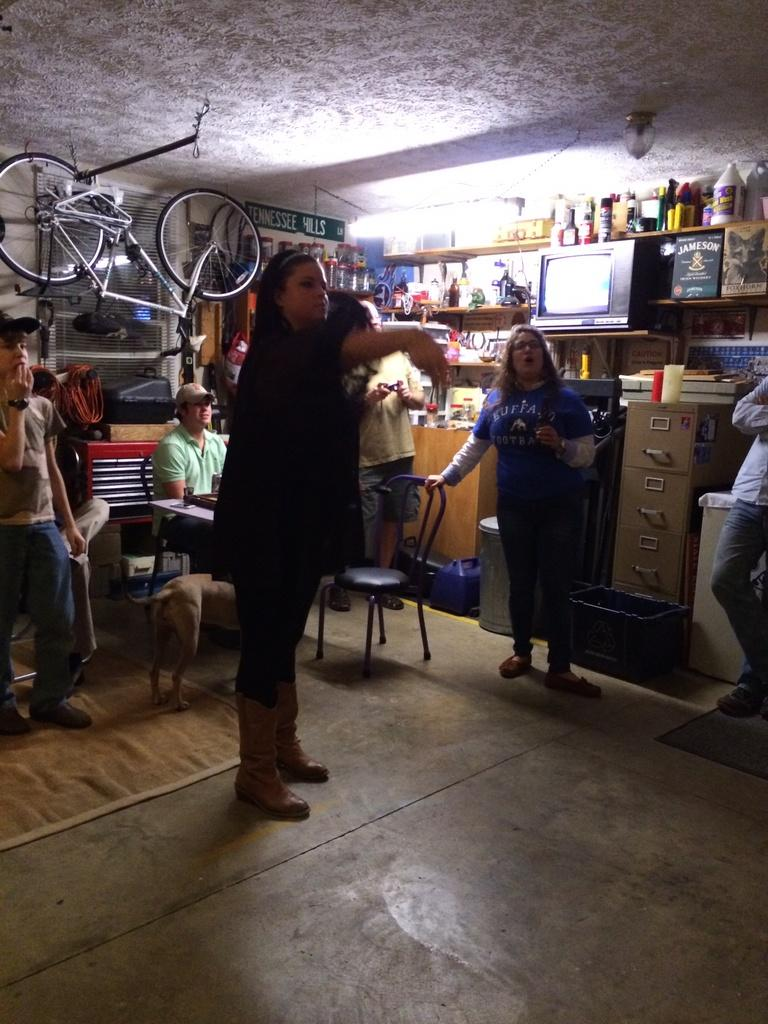How many people are in the group that is standing in the image? The number of people in the group is not specified, but there is a group of people standing in the image. What is the man in the image doing? The man is sitting on a chair in the image. What can be seen behind the people in the image? There is a bicycle behind the people in the image. What type of containers are present in the image? Bottles and a cup are visible in the image. What is visible in the background of the image? There is a wall and other unspecified objects in the background of the image. What type of machine is being used by the people in the image? There is no machine present in the image; it features a group of people standing, a man sitting on a chair, and a bicycle behind them. What disease is affecting the people in the image? There is no indication of any disease affecting the people in the image. 